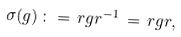<formula> <loc_0><loc_0><loc_500><loc_500>\sigma ( g ) \, \colon = \, r g r ^ { - 1 } \, = \, r g r ,</formula> 